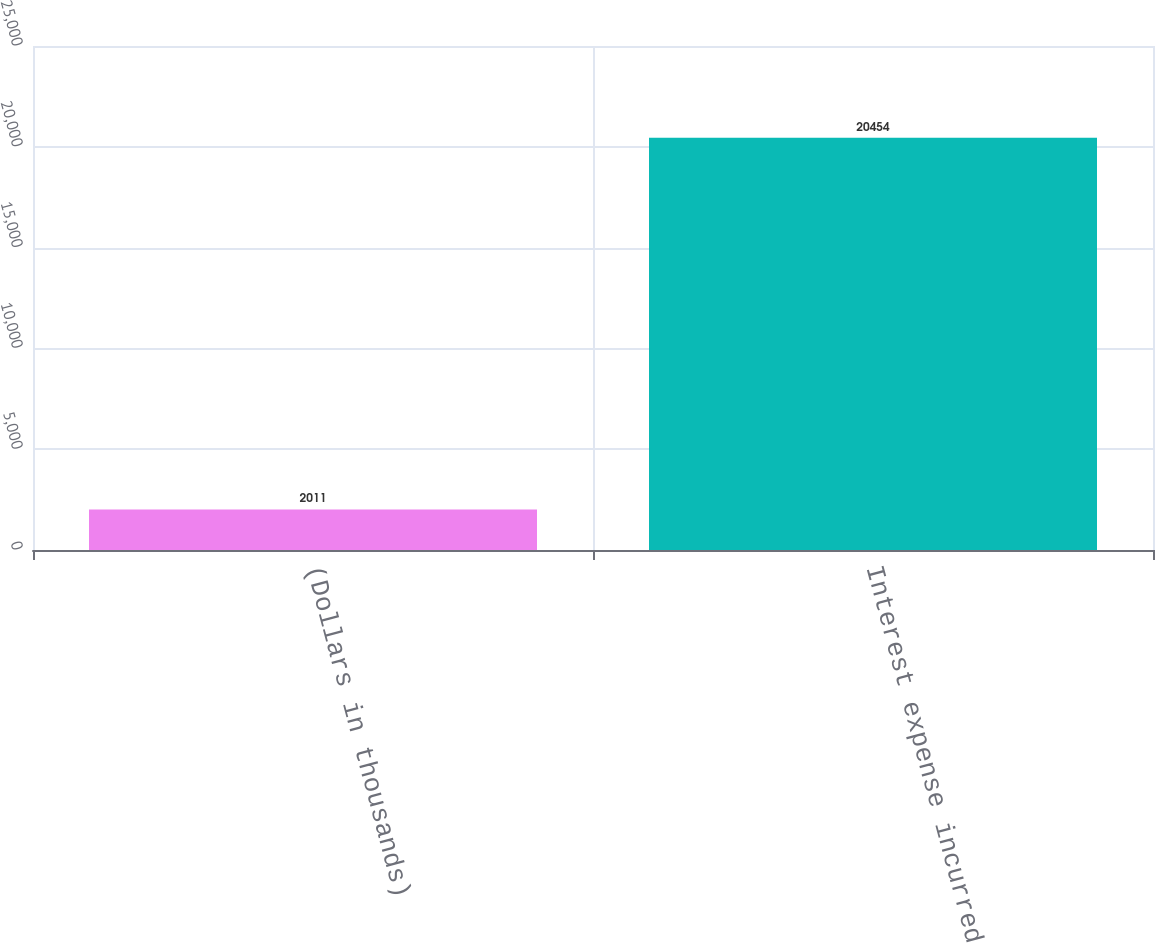Convert chart. <chart><loc_0><loc_0><loc_500><loc_500><bar_chart><fcel>(Dollars in thousands)<fcel>Interest expense incurred<nl><fcel>2011<fcel>20454<nl></chart> 